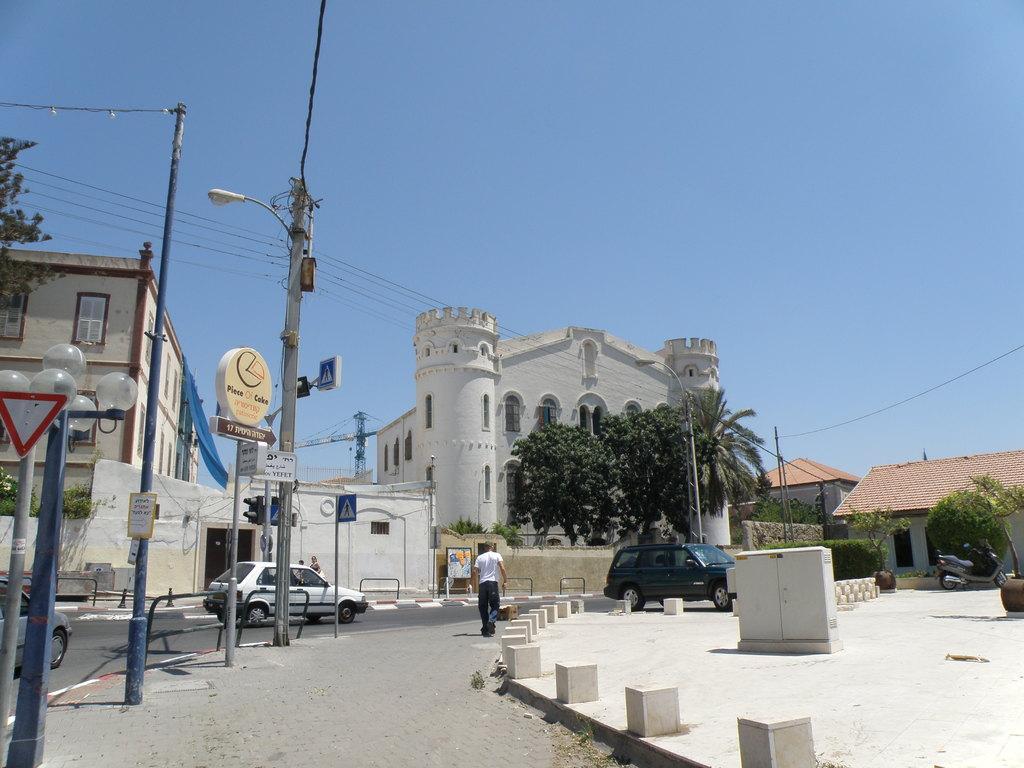Can you describe this image briefly? In this picture we can see the buildings, trees, wall, door, windows, boards, electric light poles, wire, tower and some vehicles. In the center of the image we can see a man is walking. At the bottom of the image we can see the road. At the top of the image we can see the sky. 